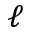<formula> <loc_0><loc_0><loc_500><loc_500>\ell</formula> 